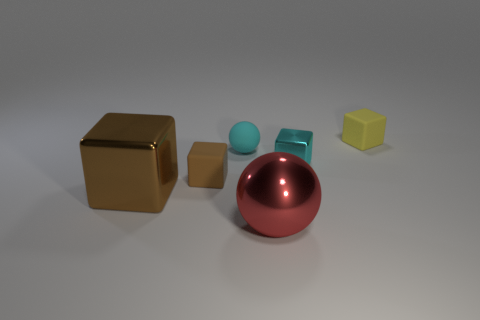How many other objects are there of the same color as the tiny rubber ball?
Offer a terse response. 1. What number of rubber objects are either large brown blocks or things?
Your answer should be compact. 3. There is a metal block that is on the right side of the big red metal thing; is it the same color as the sphere behind the big brown cube?
Offer a terse response. Yes. The brown matte object that is the same shape as the yellow object is what size?
Ensure brevity in your answer.  Small. Is the number of brown metal cubes that are in front of the tiny cyan matte ball greater than the number of big red rubber spheres?
Your response must be concise. Yes. Are the tiny cyan thing that is to the left of the big red thing and the tiny brown block made of the same material?
Provide a succinct answer. Yes. What is the size of the rubber cube on the left side of the block behind the metallic object that is behind the brown metal cube?
Keep it short and to the point. Small. There is a cyan block that is the same material as the large ball; what is its size?
Give a very brief answer. Small. The cube that is both left of the small ball and behind the big brown metallic thing is what color?
Provide a short and direct response. Brown. Do the tiny yellow thing that is right of the large brown metallic thing and the matte thing in front of the small cyan block have the same shape?
Your answer should be very brief. Yes. 